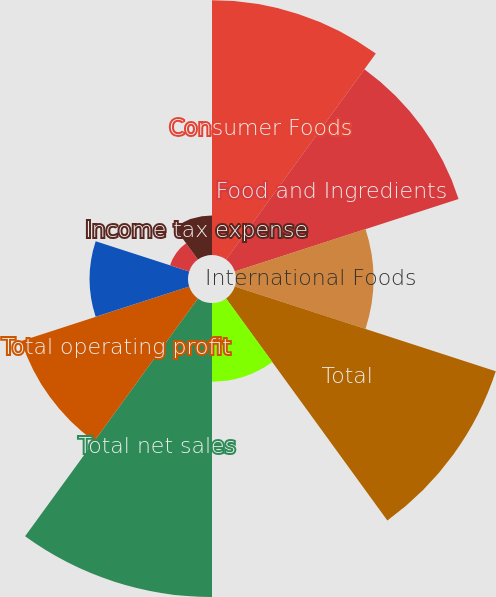Convert chart. <chart><loc_0><loc_0><loc_500><loc_500><pie_chart><fcel>Consumer Foods<fcel>Food and Ingredients<fcel>International Foods<fcel>Total<fcel>Intersegment elimination<fcel>Total net sales<fcel>Total operating profit<fcel>General corporate expenses<fcel>Interest expense net<fcel>Income tax expense<nl><fcel>15.83%<fcel>14.62%<fcel>8.54%<fcel>17.05%<fcel>4.89%<fcel>18.27%<fcel>10.97%<fcel>6.11%<fcel>1.25%<fcel>2.46%<nl></chart> 